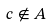Convert formula to latex. <formula><loc_0><loc_0><loc_500><loc_500>c \notin A</formula> 